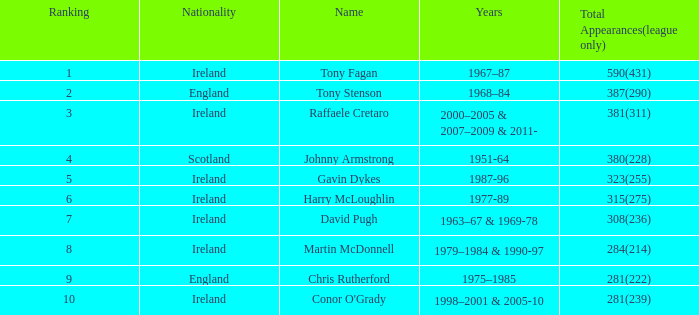Which nationality holds a rank below 7 with tony stenson as the name? England. 